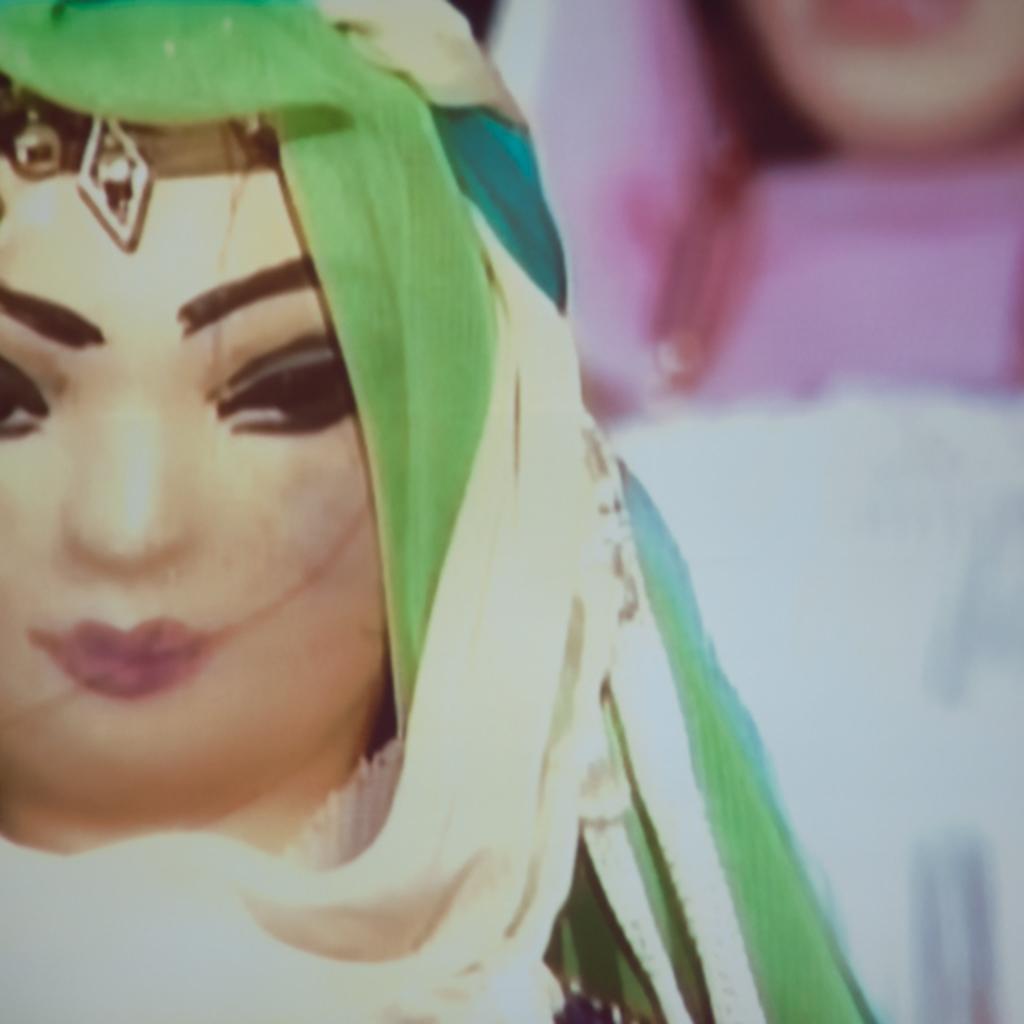Can you describe this image briefly? In this picture we can see a toy and blurry background. 